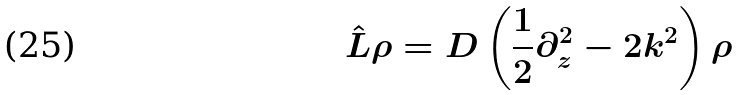Convert formula to latex. <formula><loc_0><loc_0><loc_500><loc_500>\hat { L } \rho = D \left ( \frac { 1 } { 2 } \partial _ { z } ^ { 2 } - 2 k ^ { 2 } \right ) \rho</formula> 